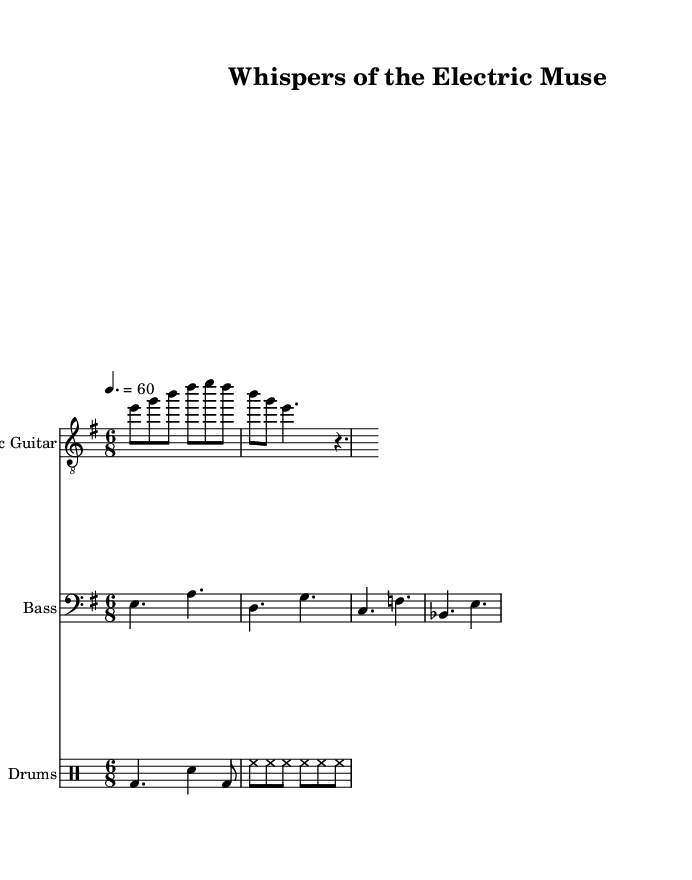What is the key signature of this music? The key signature shown in the music is E minor, which has one sharp (F#).
Answer: E minor What is the time signature of this music? The time signature displayed is 6/8, indicating six eighth-note beats in each measure.
Answer: 6/8 What is the tempo marking for this piece? The tempo is marked as 4 equals 60, indicating a moderate pace where a quarter note beats 60 times per minute.
Answer: 60 How many measures are shown for the electric guitar part? The electric guitar part in the provided segment includes two measures of music.
Answer: Two What instruments are included in this score? The score includes electric guitar, bass guitar, drums, and spoken word lyrics.
Answer: Electric guitar, bass guitar, drums, spoken word What type of rhythm is primarily used in the drums? The drums display a mix of quarter notes and eighth notes, creating a driving, syncopated rhythm typical for blues.
Answer: Quarter notes and eighth notes What is the primary thematic element present in this electric blues piece? The piece fuses electric blues with spoken word poetry, reflecting an innovative blend of musical and poetic expression.
Answer: Spoken word poetry 